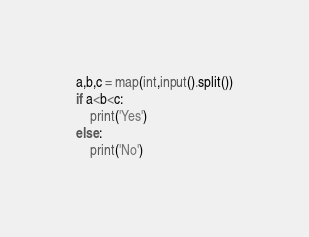Convert code to text. <code><loc_0><loc_0><loc_500><loc_500><_Python_>a,b,c = map(int,input().split())
if a<b<c:
    print('Yes')
else:
    print('No')
</code> 